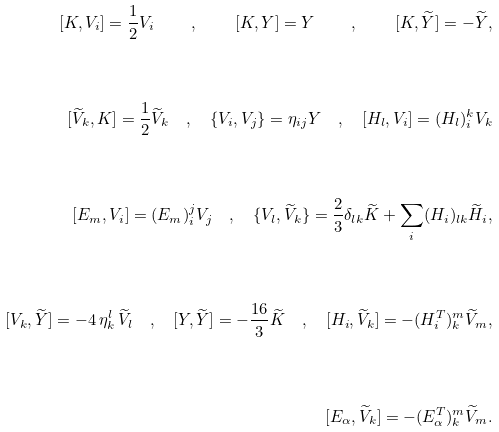<formula> <loc_0><loc_0><loc_500><loc_500>[ K , V _ { i } ] = \frac { 1 } { 2 } V _ { i } \quad , \quad [ K , Y ] = Y \quad , \quad [ K , \widetilde { Y } ] = - \widetilde { Y } , \\ \\ [ \widetilde { V } _ { k } , K ] = \frac { 1 } { 2 } \widetilde { V } _ { k } \quad , \quad \{ V _ { i } , V _ { j } \} = \eta _ { i j } Y \quad , \quad [ H _ { l } , V _ { i } ] = ( H _ { l } ) _ { i } ^ { k } V _ { k } \\ \\ [ E _ { m } , V _ { i } ] = ( E _ { m } ) _ { i } ^ { j } V _ { j } \quad , \quad \{ V _ { l } , \widetilde { V } _ { k } \} = \frac { 2 } { 3 } \delta _ { l k } \widetilde { K } + \underset { i } { \sum } ( H _ { i } ) _ { l k } \widetilde { H } _ { i } , \\ \\ [ V _ { k } , \widetilde { Y } ] = - 4 \, \eta _ { k } ^ { l } \, \widetilde { V } _ { l } \quad , \quad [ Y , \widetilde { Y } ] = - \frac { 1 6 } { 3 } \widetilde { K } \quad , \quad [ H _ { i } , \widetilde { V } _ { k } ] = - ( H _ { i } ^ { T } ) _ { k } ^ { m } \widetilde { V } _ { m } , \\ \\ [ E _ { \alpha } , \widetilde { V } _ { k } ] = - ( E _ { \alpha } ^ { T } ) _ { k } ^ { m } \widetilde { V } _ { m } .</formula> 